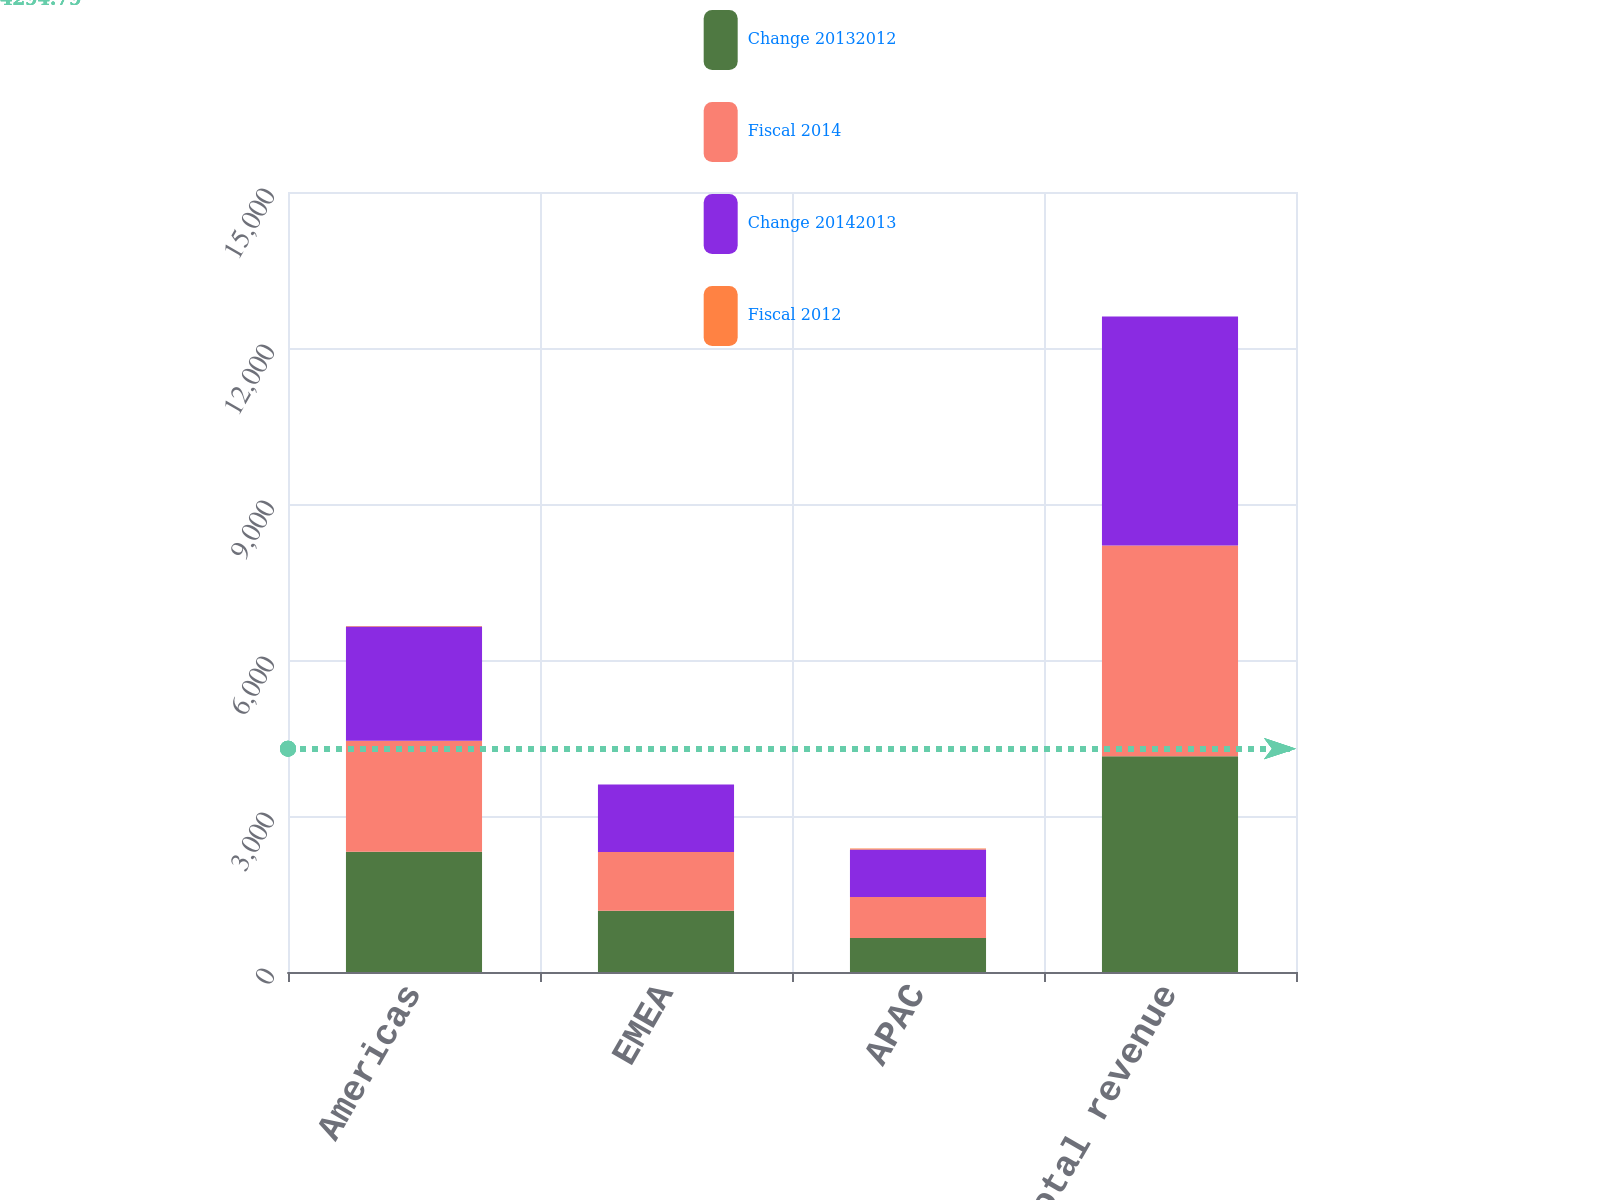Convert chart to OTSL. <chart><loc_0><loc_0><loc_500><loc_500><stacked_bar_chart><ecel><fcel>Americas<fcel>EMEA<fcel>APAC<fcel>Total revenue<nl><fcel>Change 20132012<fcel>2314.4<fcel>1179.9<fcel>652.8<fcel>4147.1<nl><fcel>Fiscal 2014<fcel>2134.4<fcel>1129.2<fcel>791.6<fcel>4055.2<nl><fcel>Change 20142013<fcel>2196.4<fcel>1294.6<fcel>912.7<fcel>4403.7<nl><fcel>Fiscal 2012<fcel>8<fcel>4<fcel>18<fcel>2<nl></chart> 